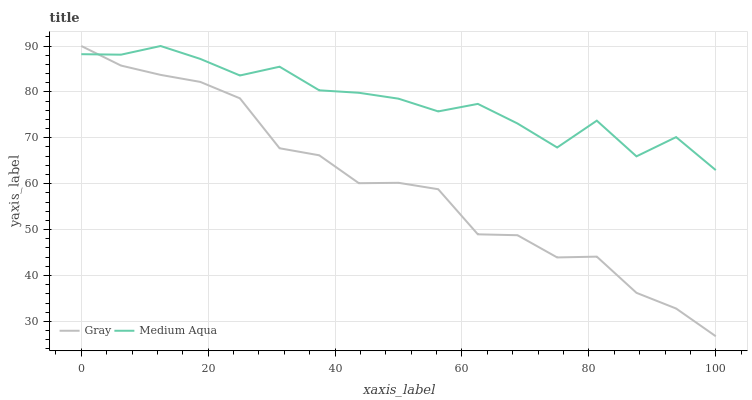Does Gray have the minimum area under the curve?
Answer yes or no. Yes. Does Medium Aqua have the maximum area under the curve?
Answer yes or no. Yes. Does Medium Aqua have the minimum area under the curve?
Answer yes or no. No. Is Gray the smoothest?
Answer yes or no. Yes. Is Medium Aqua the roughest?
Answer yes or no. Yes. Is Medium Aqua the smoothest?
Answer yes or no. No. Does Gray have the lowest value?
Answer yes or no. Yes. Does Medium Aqua have the lowest value?
Answer yes or no. No. Does Medium Aqua have the highest value?
Answer yes or no. Yes. Does Gray intersect Medium Aqua?
Answer yes or no. Yes. Is Gray less than Medium Aqua?
Answer yes or no. No. Is Gray greater than Medium Aqua?
Answer yes or no. No. 